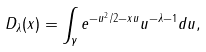<formula> <loc_0><loc_0><loc_500><loc_500>D _ { \lambda } ( x ) = \int _ { \gamma } e ^ { - u ^ { 2 } / 2 - x u } u ^ { - \lambda - 1 } d u ,</formula> 